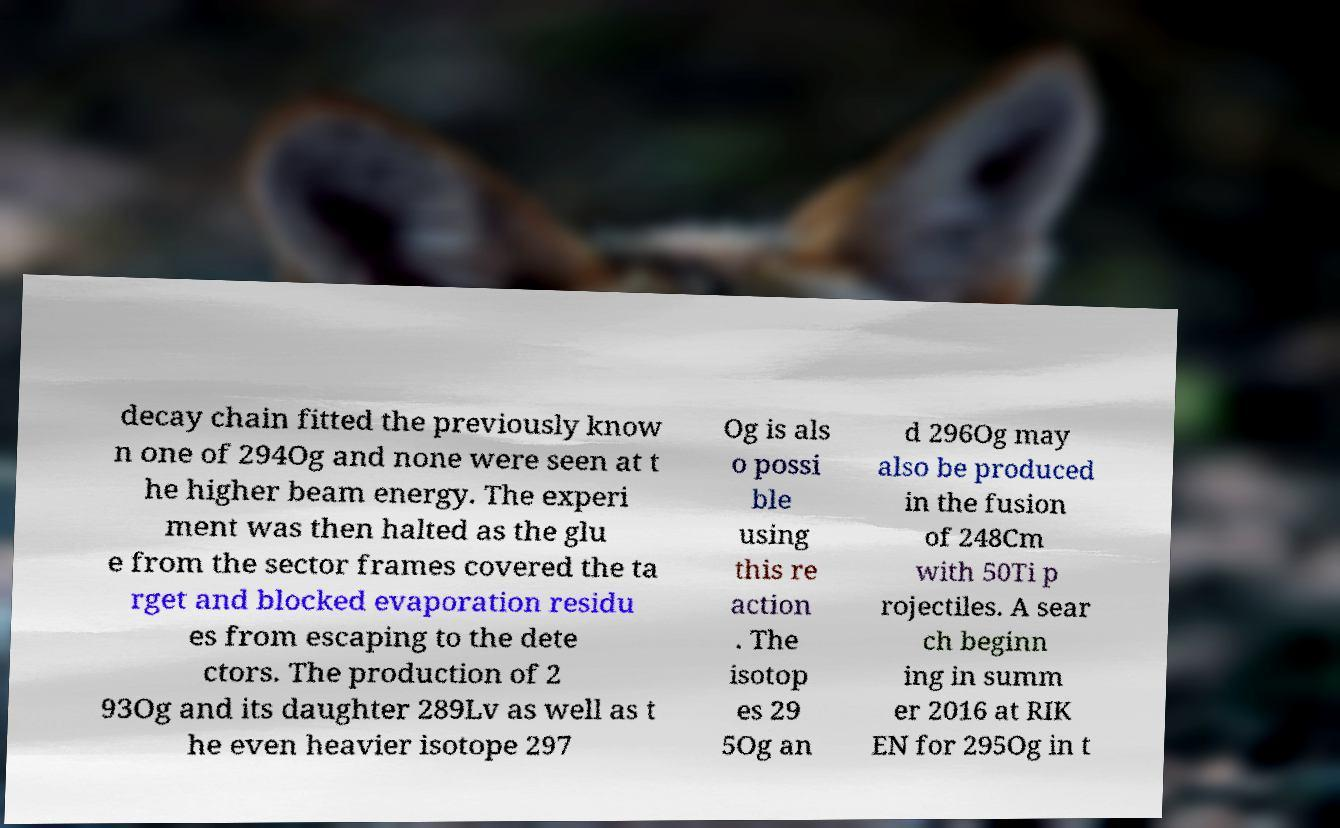For documentation purposes, I need the text within this image transcribed. Could you provide that? decay chain fitted the previously know n one of 294Og and none were seen at t he higher beam energy. The experi ment was then halted as the glu e from the sector frames covered the ta rget and blocked evaporation residu es from escaping to the dete ctors. The production of 2 93Og and its daughter 289Lv as well as t he even heavier isotope 297 Og is als o possi ble using this re action . The isotop es 29 5Og an d 296Og may also be produced in the fusion of 248Cm with 50Ti p rojectiles. A sear ch beginn ing in summ er 2016 at RIK EN for 295Og in t 